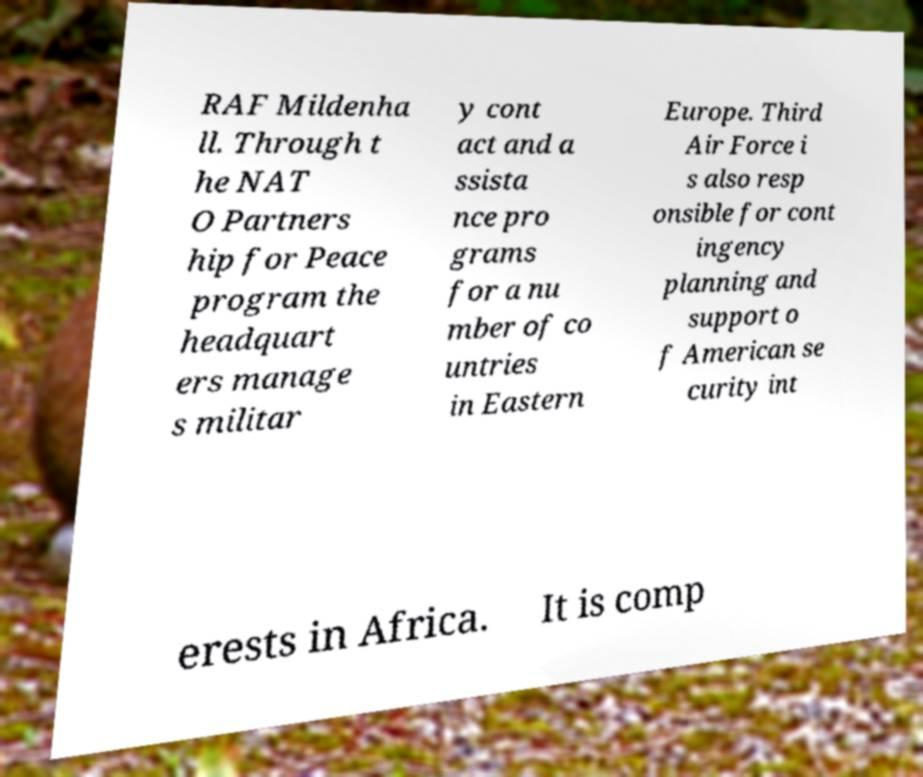Can you read and provide the text displayed in the image?This photo seems to have some interesting text. Can you extract and type it out for me? RAF Mildenha ll. Through t he NAT O Partners hip for Peace program the headquart ers manage s militar y cont act and a ssista nce pro grams for a nu mber of co untries in Eastern Europe. Third Air Force i s also resp onsible for cont ingency planning and support o f American se curity int erests in Africa. It is comp 